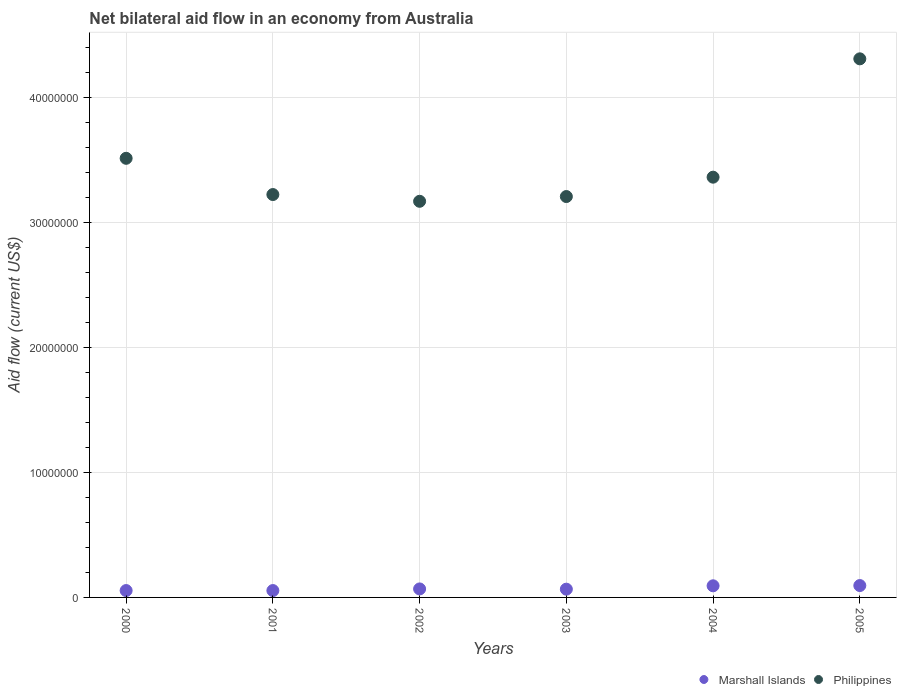How many different coloured dotlines are there?
Your response must be concise. 2. Is the number of dotlines equal to the number of legend labels?
Provide a succinct answer. Yes. What is the net bilateral aid flow in Marshall Islands in 2004?
Keep it short and to the point. 9.30e+05. Across all years, what is the maximum net bilateral aid flow in Philippines?
Keep it short and to the point. 4.31e+07. In which year was the net bilateral aid flow in Philippines maximum?
Offer a terse response. 2005. In which year was the net bilateral aid flow in Philippines minimum?
Your response must be concise. 2002. What is the total net bilateral aid flow in Philippines in the graph?
Provide a succinct answer. 2.08e+08. What is the difference between the net bilateral aid flow in Philippines in 2001 and that in 2004?
Provide a succinct answer. -1.39e+06. What is the difference between the net bilateral aid flow in Marshall Islands in 2003 and the net bilateral aid flow in Philippines in 2000?
Provide a short and direct response. -3.45e+07. What is the average net bilateral aid flow in Philippines per year?
Make the answer very short. 3.46e+07. In the year 2003, what is the difference between the net bilateral aid flow in Philippines and net bilateral aid flow in Marshall Islands?
Provide a succinct answer. 3.14e+07. In how many years, is the net bilateral aid flow in Marshall Islands greater than 26000000 US$?
Your response must be concise. 0. What is the ratio of the net bilateral aid flow in Marshall Islands in 2002 to that in 2004?
Keep it short and to the point. 0.73. Is the net bilateral aid flow in Marshall Islands in 2003 less than that in 2004?
Provide a succinct answer. Yes. What is the difference between the highest and the second highest net bilateral aid flow in Philippines?
Your answer should be very brief. 7.96e+06. In how many years, is the net bilateral aid flow in Philippines greater than the average net bilateral aid flow in Philippines taken over all years?
Keep it short and to the point. 2. Is the sum of the net bilateral aid flow in Marshall Islands in 2003 and 2004 greater than the maximum net bilateral aid flow in Philippines across all years?
Give a very brief answer. No. Does the net bilateral aid flow in Marshall Islands monotonically increase over the years?
Offer a terse response. No. Is the net bilateral aid flow in Philippines strictly greater than the net bilateral aid flow in Marshall Islands over the years?
Provide a succinct answer. Yes. Is the net bilateral aid flow in Philippines strictly less than the net bilateral aid flow in Marshall Islands over the years?
Your response must be concise. No. How many dotlines are there?
Keep it short and to the point. 2. How many years are there in the graph?
Give a very brief answer. 6. Are the values on the major ticks of Y-axis written in scientific E-notation?
Provide a short and direct response. No. How are the legend labels stacked?
Give a very brief answer. Horizontal. What is the title of the graph?
Keep it short and to the point. Net bilateral aid flow in an economy from Australia. What is the Aid flow (current US$) in Philippines in 2000?
Your answer should be very brief. 3.51e+07. What is the Aid flow (current US$) in Marshall Islands in 2001?
Ensure brevity in your answer.  5.50e+05. What is the Aid flow (current US$) in Philippines in 2001?
Ensure brevity in your answer.  3.22e+07. What is the Aid flow (current US$) of Marshall Islands in 2002?
Keep it short and to the point. 6.80e+05. What is the Aid flow (current US$) in Philippines in 2002?
Provide a succinct answer. 3.17e+07. What is the Aid flow (current US$) in Marshall Islands in 2003?
Your response must be concise. 6.60e+05. What is the Aid flow (current US$) in Philippines in 2003?
Give a very brief answer. 3.21e+07. What is the Aid flow (current US$) of Marshall Islands in 2004?
Make the answer very short. 9.30e+05. What is the Aid flow (current US$) in Philippines in 2004?
Your answer should be very brief. 3.36e+07. What is the Aid flow (current US$) of Marshall Islands in 2005?
Your answer should be compact. 9.50e+05. What is the Aid flow (current US$) of Philippines in 2005?
Give a very brief answer. 4.31e+07. Across all years, what is the maximum Aid flow (current US$) of Marshall Islands?
Provide a succinct answer. 9.50e+05. Across all years, what is the maximum Aid flow (current US$) in Philippines?
Make the answer very short. 4.31e+07. Across all years, what is the minimum Aid flow (current US$) in Philippines?
Your response must be concise. 3.17e+07. What is the total Aid flow (current US$) of Marshall Islands in the graph?
Your answer should be compact. 4.32e+06. What is the total Aid flow (current US$) in Philippines in the graph?
Your answer should be compact. 2.08e+08. What is the difference between the Aid flow (current US$) in Marshall Islands in 2000 and that in 2001?
Your answer should be compact. 0. What is the difference between the Aid flow (current US$) in Philippines in 2000 and that in 2001?
Your response must be concise. 2.90e+06. What is the difference between the Aid flow (current US$) of Philippines in 2000 and that in 2002?
Give a very brief answer. 3.44e+06. What is the difference between the Aid flow (current US$) in Marshall Islands in 2000 and that in 2003?
Your answer should be compact. -1.10e+05. What is the difference between the Aid flow (current US$) of Philippines in 2000 and that in 2003?
Keep it short and to the point. 3.06e+06. What is the difference between the Aid flow (current US$) in Marshall Islands in 2000 and that in 2004?
Your response must be concise. -3.80e+05. What is the difference between the Aid flow (current US$) of Philippines in 2000 and that in 2004?
Your answer should be compact. 1.51e+06. What is the difference between the Aid flow (current US$) in Marshall Islands in 2000 and that in 2005?
Ensure brevity in your answer.  -4.00e+05. What is the difference between the Aid flow (current US$) in Philippines in 2000 and that in 2005?
Provide a succinct answer. -7.96e+06. What is the difference between the Aid flow (current US$) of Marshall Islands in 2001 and that in 2002?
Offer a very short reply. -1.30e+05. What is the difference between the Aid flow (current US$) in Philippines in 2001 and that in 2002?
Offer a terse response. 5.40e+05. What is the difference between the Aid flow (current US$) of Marshall Islands in 2001 and that in 2004?
Your response must be concise. -3.80e+05. What is the difference between the Aid flow (current US$) in Philippines in 2001 and that in 2004?
Provide a succinct answer. -1.39e+06. What is the difference between the Aid flow (current US$) of Marshall Islands in 2001 and that in 2005?
Keep it short and to the point. -4.00e+05. What is the difference between the Aid flow (current US$) in Philippines in 2001 and that in 2005?
Give a very brief answer. -1.09e+07. What is the difference between the Aid flow (current US$) in Marshall Islands in 2002 and that in 2003?
Give a very brief answer. 2.00e+04. What is the difference between the Aid flow (current US$) in Philippines in 2002 and that in 2003?
Make the answer very short. -3.80e+05. What is the difference between the Aid flow (current US$) in Philippines in 2002 and that in 2004?
Ensure brevity in your answer.  -1.93e+06. What is the difference between the Aid flow (current US$) of Marshall Islands in 2002 and that in 2005?
Make the answer very short. -2.70e+05. What is the difference between the Aid flow (current US$) of Philippines in 2002 and that in 2005?
Keep it short and to the point. -1.14e+07. What is the difference between the Aid flow (current US$) in Marshall Islands in 2003 and that in 2004?
Offer a very short reply. -2.70e+05. What is the difference between the Aid flow (current US$) in Philippines in 2003 and that in 2004?
Keep it short and to the point. -1.55e+06. What is the difference between the Aid flow (current US$) in Marshall Islands in 2003 and that in 2005?
Keep it short and to the point. -2.90e+05. What is the difference between the Aid flow (current US$) in Philippines in 2003 and that in 2005?
Ensure brevity in your answer.  -1.10e+07. What is the difference between the Aid flow (current US$) of Marshall Islands in 2004 and that in 2005?
Provide a short and direct response. -2.00e+04. What is the difference between the Aid flow (current US$) in Philippines in 2004 and that in 2005?
Offer a terse response. -9.47e+06. What is the difference between the Aid flow (current US$) in Marshall Islands in 2000 and the Aid flow (current US$) in Philippines in 2001?
Provide a succinct answer. -3.17e+07. What is the difference between the Aid flow (current US$) in Marshall Islands in 2000 and the Aid flow (current US$) in Philippines in 2002?
Offer a terse response. -3.12e+07. What is the difference between the Aid flow (current US$) in Marshall Islands in 2000 and the Aid flow (current US$) in Philippines in 2003?
Keep it short and to the point. -3.15e+07. What is the difference between the Aid flow (current US$) in Marshall Islands in 2000 and the Aid flow (current US$) in Philippines in 2004?
Offer a very short reply. -3.31e+07. What is the difference between the Aid flow (current US$) in Marshall Islands in 2000 and the Aid flow (current US$) in Philippines in 2005?
Provide a succinct answer. -4.26e+07. What is the difference between the Aid flow (current US$) in Marshall Islands in 2001 and the Aid flow (current US$) in Philippines in 2002?
Offer a very short reply. -3.12e+07. What is the difference between the Aid flow (current US$) of Marshall Islands in 2001 and the Aid flow (current US$) of Philippines in 2003?
Your answer should be very brief. -3.15e+07. What is the difference between the Aid flow (current US$) in Marshall Islands in 2001 and the Aid flow (current US$) in Philippines in 2004?
Your response must be concise. -3.31e+07. What is the difference between the Aid flow (current US$) in Marshall Islands in 2001 and the Aid flow (current US$) in Philippines in 2005?
Make the answer very short. -4.26e+07. What is the difference between the Aid flow (current US$) in Marshall Islands in 2002 and the Aid flow (current US$) in Philippines in 2003?
Offer a very short reply. -3.14e+07. What is the difference between the Aid flow (current US$) of Marshall Islands in 2002 and the Aid flow (current US$) of Philippines in 2004?
Provide a succinct answer. -3.30e+07. What is the difference between the Aid flow (current US$) in Marshall Islands in 2002 and the Aid flow (current US$) in Philippines in 2005?
Make the answer very short. -4.24e+07. What is the difference between the Aid flow (current US$) in Marshall Islands in 2003 and the Aid flow (current US$) in Philippines in 2004?
Your answer should be very brief. -3.30e+07. What is the difference between the Aid flow (current US$) of Marshall Islands in 2003 and the Aid flow (current US$) of Philippines in 2005?
Your response must be concise. -4.24e+07. What is the difference between the Aid flow (current US$) of Marshall Islands in 2004 and the Aid flow (current US$) of Philippines in 2005?
Your answer should be compact. -4.22e+07. What is the average Aid flow (current US$) in Marshall Islands per year?
Offer a very short reply. 7.20e+05. What is the average Aid flow (current US$) of Philippines per year?
Provide a short and direct response. 3.46e+07. In the year 2000, what is the difference between the Aid flow (current US$) of Marshall Islands and Aid flow (current US$) of Philippines?
Your answer should be compact. -3.46e+07. In the year 2001, what is the difference between the Aid flow (current US$) of Marshall Islands and Aid flow (current US$) of Philippines?
Provide a succinct answer. -3.17e+07. In the year 2002, what is the difference between the Aid flow (current US$) of Marshall Islands and Aid flow (current US$) of Philippines?
Provide a succinct answer. -3.10e+07. In the year 2003, what is the difference between the Aid flow (current US$) in Marshall Islands and Aid flow (current US$) in Philippines?
Your answer should be compact. -3.14e+07. In the year 2004, what is the difference between the Aid flow (current US$) of Marshall Islands and Aid flow (current US$) of Philippines?
Provide a short and direct response. -3.27e+07. In the year 2005, what is the difference between the Aid flow (current US$) in Marshall Islands and Aid flow (current US$) in Philippines?
Your response must be concise. -4.22e+07. What is the ratio of the Aid flow (current US$) in Marshall Islands in 2000 to that in 2001?
Keep it short and to the point. 1. What is the ratio of the Aid flow (current US$) in Philippines in 2000 to that in 2001?
Keep it short and to the point. 1.09. What is the ratio of the Aid flow (current US$) in Marshall Islands in 2000 to that in 2002?
Keep it short and to the point. 0.81. What is the ratio of the Aid flow (current US$) of Philippines in 2000 to that in 2002?
Provide a short and direct response. 1.11. What is the ratio of the Aid flow (current US$) in Philippines in 2000 to that in 2003?
Provide a succinct answer. 1.1. What is the ratio of the Aid flow (current US$) of Marshall Islands in 2000 to that in 2004?
Offer a terse response. 0.59. What is the ratio of the Aid flow (current US$) in Philippines in 2000 to that in 2004?
Provide a succinct answer. 1.04. What is the ratio of the Aid flow (current US$) in Marshall Islands in 2000 to that in 2005?
Offer a very short reply. 0.58. What is the ratio of the Aid flow (current US$) of Philippines in 2000 to that in 2005?
Offer a terse response. 0.82. What is the ratio of the Aid flow (current US$) of Marshall Islands in 2001 to that in 2002?
Your response must be concise. 0.81. What is the ratio of the Aid flow (current US$) of Marshall Islands in 2001 to that in 2003?
Your answer should be very brief. 0.83. What is the ratio of the Aid flow (current US$) in Marshall Islands in 2001 to that in 2004?
Give a very brief answer. 0.59. What is the ratio of the Aid flow (current US$) of Philippines in 2001 to that in 2004?
Offer a terse response. 0.96. What is the ratio of the Aid flow (current US$) of Marshall Islands in 2001 to that in 2005?
Give a very brief answer. 0.58. What is the ratio of the Aid flow (current US$) in Philippines in 2001 to that in 2005?
Keep it short and to the point. 0.75. What is the ratio of the Aid flow (current US$) of Marshall Islands in 2002 to that in 2003?
Ensure brevity in your answer.  1.03. What is the ratio of the Aid flow (current US$) of Marshall Islands in 2002 to that in 2004?
Your answer should be very brief. 0.73. What is the ratio of the Aid flow (current US$) in Philippines in 2002 to that in 2004?
Offer a very short reply. 0.94. What is the ratio of the Aid flow (current US$) of Marshall Islands in 2002 to that in 2005?
Offer a very short reply. 0.72. What is the ratio of the Aid flow (current US$) in Philippines in 2002 to that in 2005?
Offer a terse response. 0.74. What is the ratio of the Aid flow (current US$) of Marshall Islands in 2003 to that in 2004?
Make the answer very short. 0.71. What is the ratio of the Aid flow (current US$) in Philippines in 2003 to that in 2004?
Make the answer very short. 0.95. What is the ratio of the Aid flow (current US$) of Marshall Islands in 2003 to that in 2005?
Your answer should be very brief. 0.69. What is the ratio of the Aid flow (current US$) in Philippines in 2003 to that in 2005?
Offer a very short reply. 0.74. What is the ratio of the Aid flow (current US$) in Marshall Islands in 2004 to that in 2005?
Ensure brevity in your answer.  0.98. What is the ratio of the Aid flow (current US$) of Philippines in 2004 to that in 2005?
Ensure brevity in your answer.  0.78. What is the difference between the highest and the second highest Aid flow (current US$) in Marshall Islands?
Provide a succinct answer. 2.00e+04. What is the difference between the highest and the second highest Aid flow (current US$) of Philippines?
Provide a short and direct response. 7.96e+06. What is the difference between the highest and the lowest Aid flow (current US$) in Marshall Islands?
Provide a short and direct response. 4.00e+05. What is the difference between the highest and the lowest Aid flow (current US$) of Philippines?
Provide a succinct answer. 1.14e+07. 